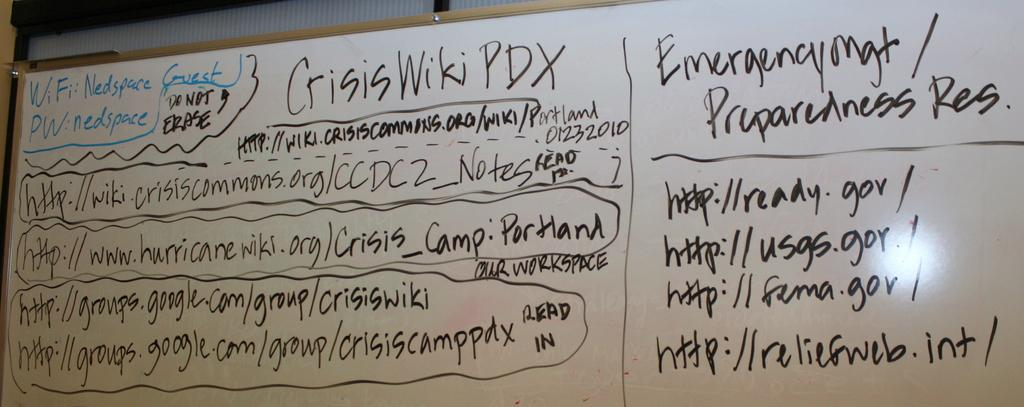<image>
Describe the image concisely. White board which tells the wifi and the password on there. 